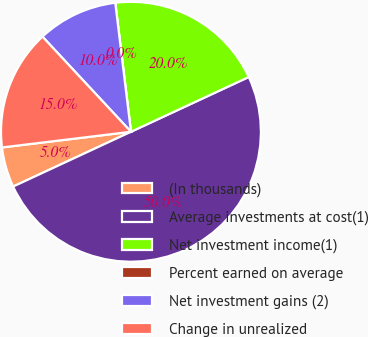Convert chart. <chart><loc_0><loc_0><loc_500><loc_500><pie_chart><fcel>(In thousands)<fcel>Average investments at cost(1)<fcel>Net investment income(1)<fcel>Percent earned on average<fcel>Net investment gains (2)<fcel>Change in unrealized<nl><fcel>5.0%<fcel>50.0%<fcel>20.0%<fcel>0.0%<fcel>10.0%<fcel>15.0%<nl></chart> 